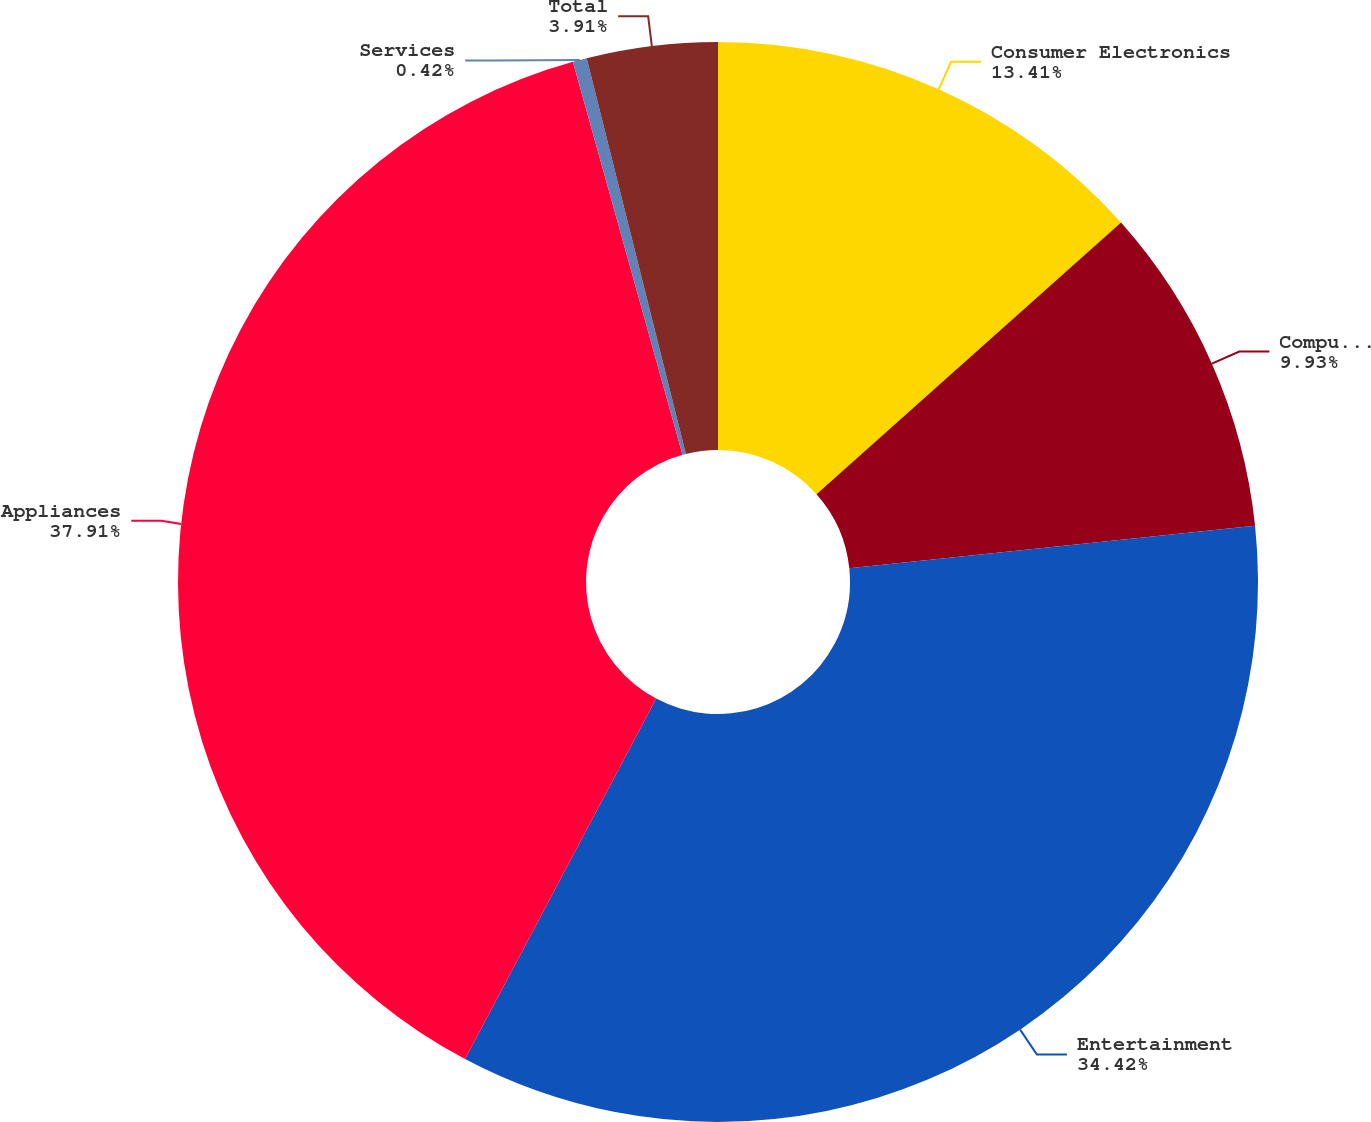Convert chart to OTSL. <chart><loc_0><loc_0><loc_500><loc_500><pie_chart><fcel>Consumer Electronics<fcel>Computing and Mobile Phones<fcel>Entertainment<fcel>Appliances<fcel>Services<fcel>Total<nl><fcel>13.41%<fcel>9.93%<fcel>34.42%<fcel>37.91%<fcel>0.42%<fcel>3.91%<nl></chart> 